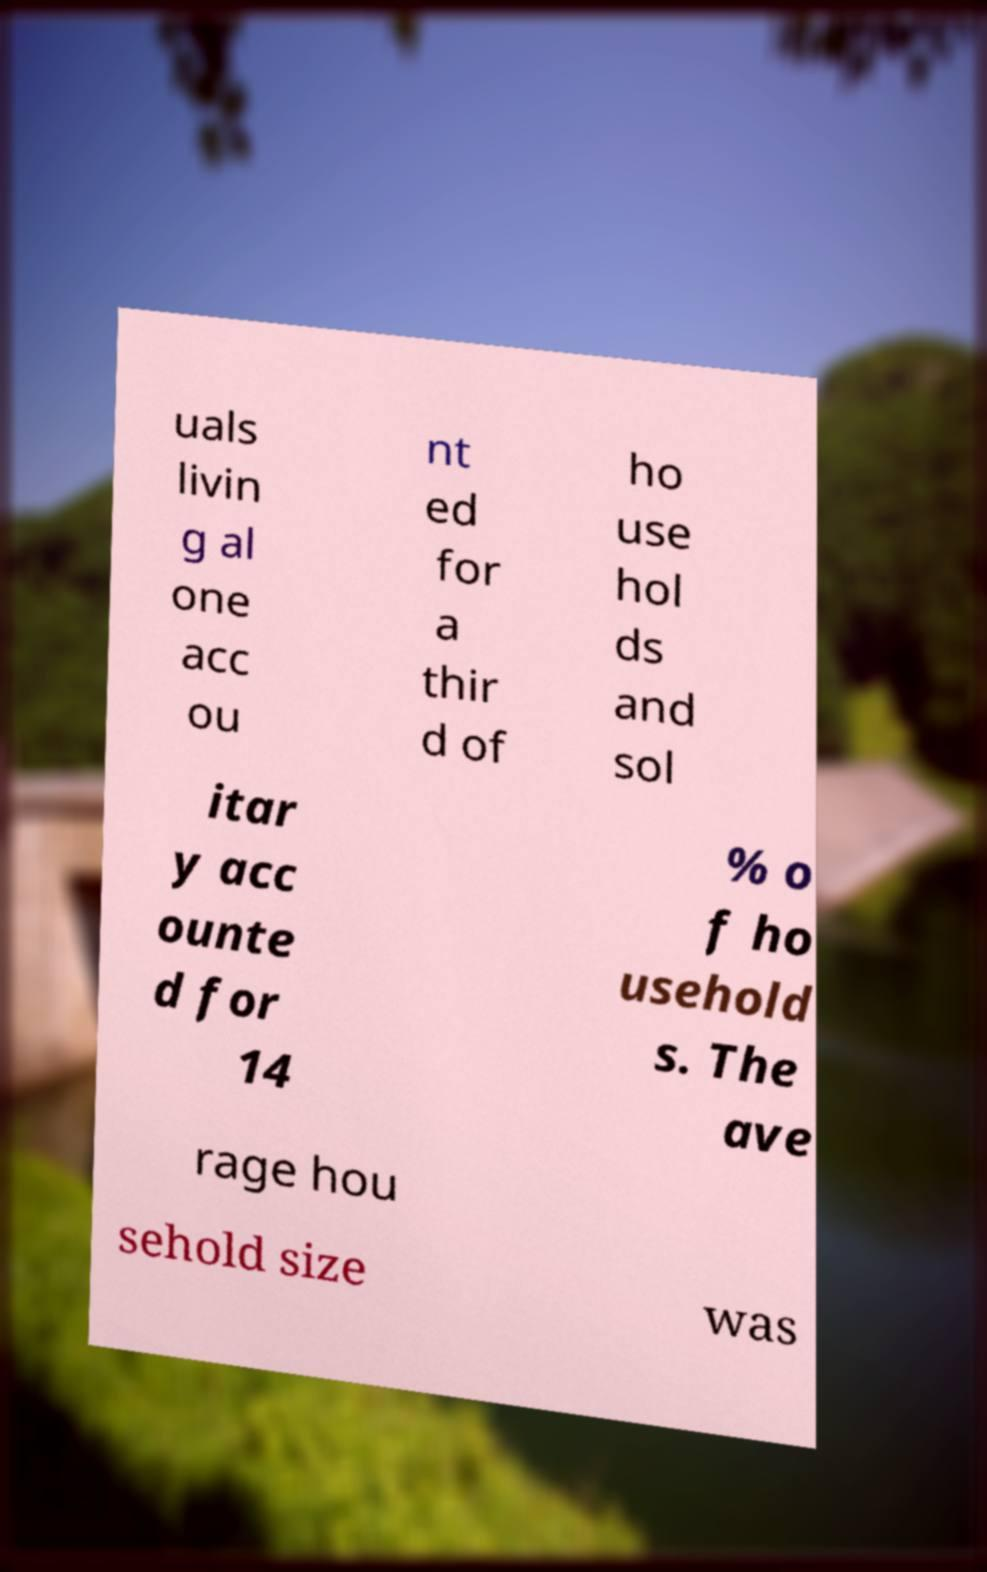Could you extract and type out the text from this image? uals livin g al one acc ou nt ed for a thir d of ho use hol ds and sol itar y acc ounte d for 14 % o f ho usehold s. The ave rage hou sehold size was 